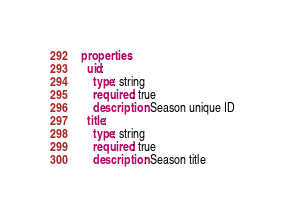<code> <loc_0><loc_0><loc_500><loc_500><_YAML_>properties:
  uid:
    type: string
    required: true
    description: Season unique ID
  title:
    type: string
    required: true
    description: Season title
</code> 